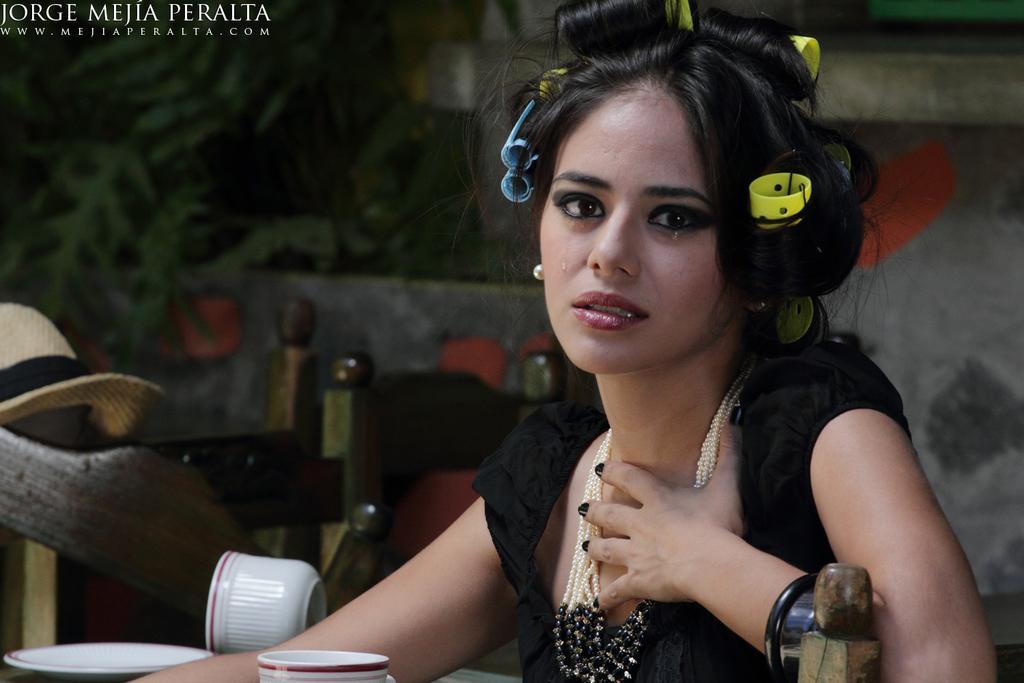Can you describe this image briefly? In this image I see a woman over here who is wearing black dress and I see the jewelry around her neck and I see the tears and I see a hat over here and I see few more things and I see the watermark over here. 